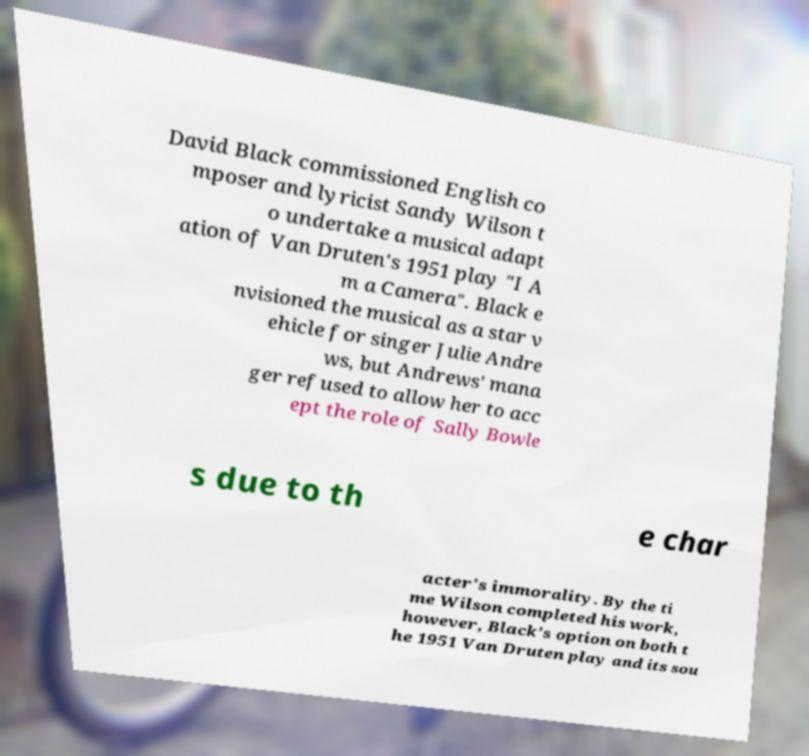What messages or text are displayed in this image? I need them in a readable, typed format. David Black commissioned English co mposer and lyricist Sandy Wilson t o undertake a musical adapt ation of Van Druten's 1951 play "I A m a Camera". Black e nvisioned the musical as a star v ehicle for singer Julie Andre ws, but Andrews' mana ger refused to allow her to acc ept the role of Sally Bowle s due to th e char acter's immorality. By the ti me Wilson completed his work, however, Black's option on both t he 1951 Van Druten play and its sou 